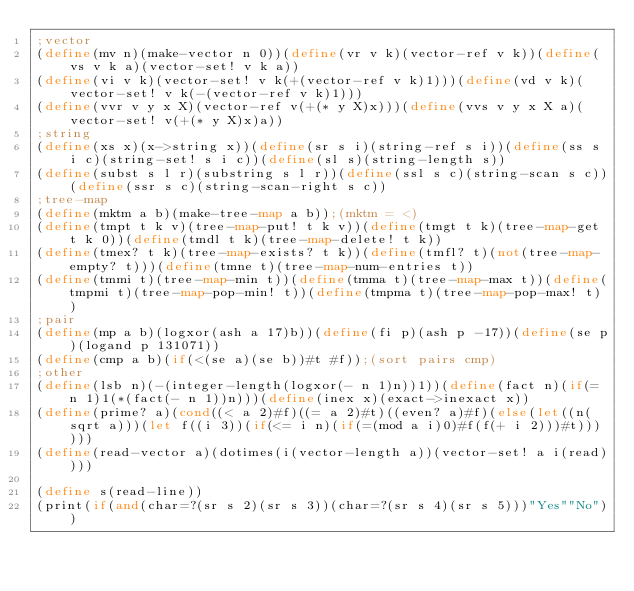Convert code to text. <code><loc_0><loc_0><loc_500><loc_500><_Scheme_>;vector
(define(mv n)(make-vector n 0))(define(vr v k)(vector-ref v k))(define(vs v k a)(vector-set! v k a))
(define(vi v k)(vector-set! v k(+(vector-ref v k)1)))(define(vd v k)(vector-set! v k(-(vector-ref v k)1)))
(define(vvr v y x X)(vector-ref v(+(* y X)x)))(define(vvs v y x X a)(vector-set! v(+(* y X)x)a))
;string
(define(xs x)(x->string x))(define(sr s i)(string-ref s i))(define(ss s i c)(string-set! s i c))(define(sl s)(string-length s))
(define(subst s l r)(substring s l r))(define(ssl s c)(string-scan s c))(define(ssr s c)(string-scan-right s c))
;tree-map
(define(mktm a b)(make-tree-map a b));(mktm = <)
(define(tmpt t k v)(tree-map-put! t k v))(define(tmgt t k)(tree-map-get t k 0))(define(tmdl t k)(tree-map-delete! t k))
(define(tmex? t k)(tree-map-exists? t k))(define(tmfl? t)(not(tree-map-empty? t)))(define(tmne t)(tree-map-num-entries t))
(define(tmmi t)(tree-map-min t))(define(tmma t)(tree-map-max t))(define(tmpmi t)(tree-map-pop-min! t))(define(tmpma t)(tree-map-pop-max! t))
;pair
(define(mp a b)(logxor(ash a 17)b))(define(fi p)(ash p -17))(define(se p)(logand p 131071))
(define(cmp a b)(if(<(se a)(se b))#t #f));(sort pairs cmp)
;other
(define(lsb n)(-(integer-length(logxor(- n 1)n))1))(define(fact n)(if(= n 1)1(*(fact(- n 1))n)))(define(inex x)(exact->inexact x))
(define(prime? a)(cond((< a 2)#f)((= a 2)#t)((even? a)#f)(else(let((n(sqrt a)))(let f((i 3))(if(<= i n)(if(=(mod a i)0)#f(f(+ i 2)))#t))))))
(define(read-vector a)(dotimes(i(vector-length a))(vector-set! a i(read))))

(define s(read-line))
(print(if(and(char=?(sr s 2)(sr s 3))(char=?(sr s 4)(sr s 5)))"Yes""No"))
</code> 